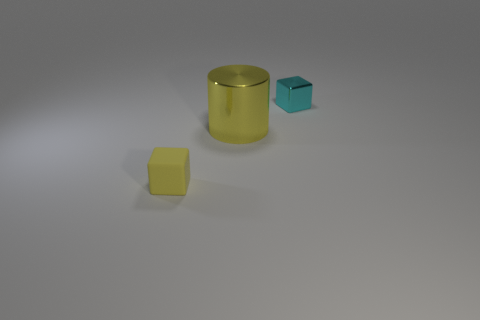Add 3 large cylinders. How many objects exist? 6 Subtract all blocks. How many objects are left? 1 Add 3 big yellow metallic cylinders. How many big yellow metallic cylinders are left? 4 Add 2 purple matte cylinders. How many purple matte cylinders exist? 2 Subtract all cyan cubes. How many cubes are left? 1 Subtract 0 blue cylinders. How many objects are left? 3 Subtract all cyan cylinders. Subtract all brown cubes. How many cylinders are left? 1 Subtract all matte objects. Subtract all big gray shiny cylinders. How many objects are left? 2 